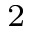<formula> <loc_0><loc_0><loc_500><loc_500>^ { 2 }</formula> 